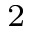<formula> <loc_0><loc_0><loc_500><loc_500>^ { 2 }</formula> 